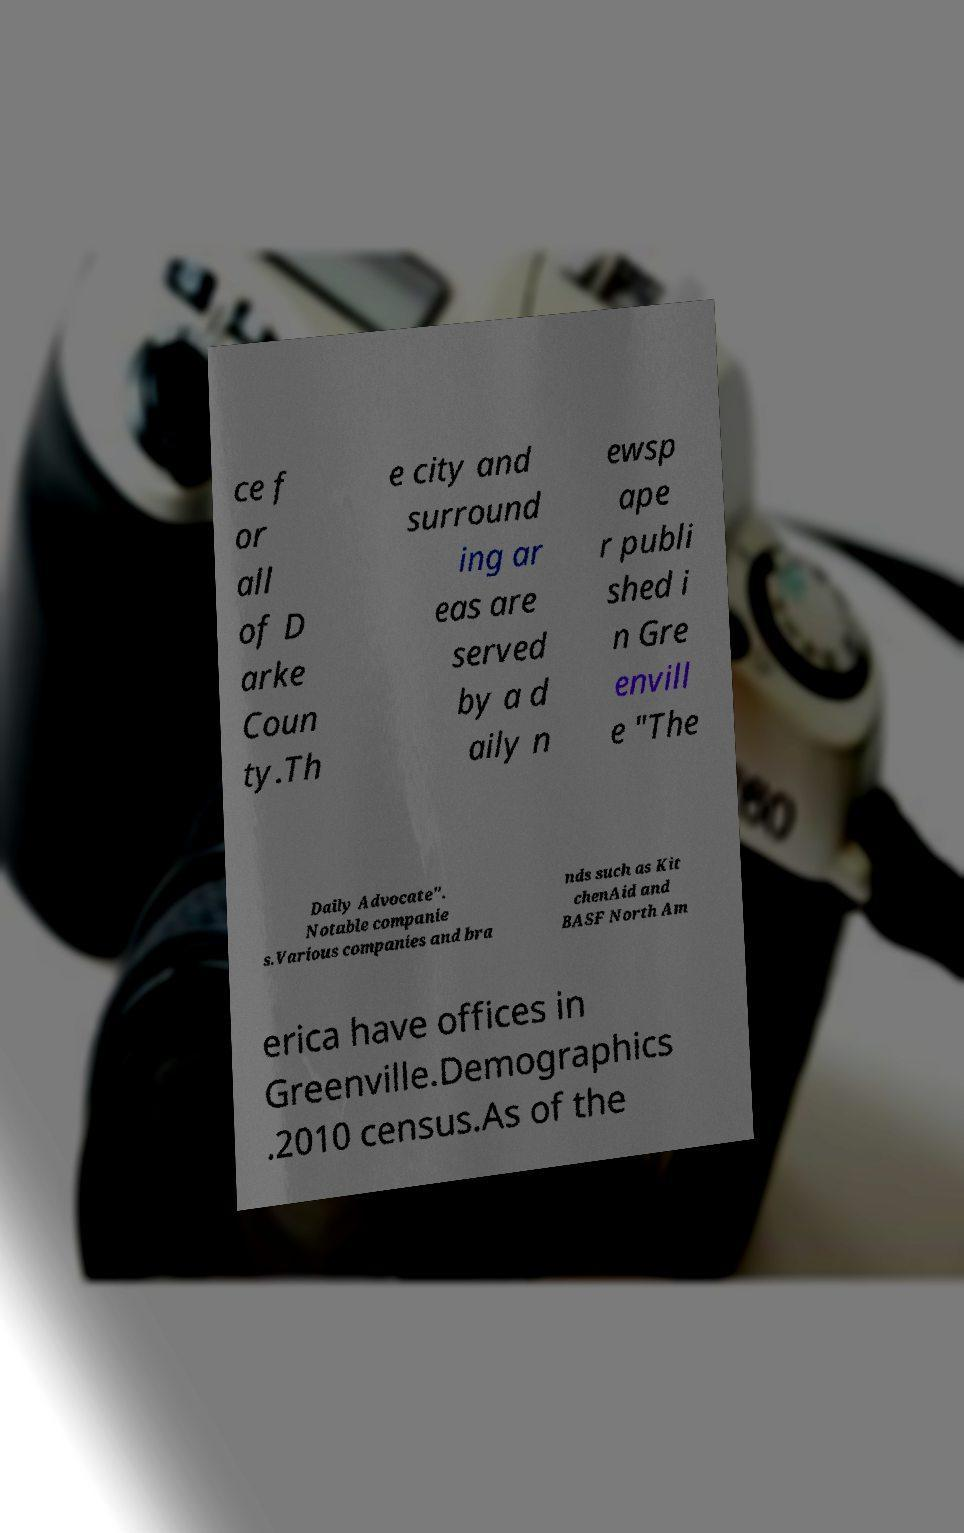I need the written content from this picture converted into text. Can you do that? ce f or all of D arke Coun ty.Th e city and surround ing ar eas are served by a d aily n ewsp ape r publi shed i n Gre envill e "The Daily Advocate". Notable companie s.Various companies and bra nds such as Kit chenAid and BASF North Am erica have offices in Greenville.Demographics .2010 census.As of the 